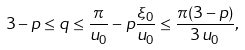<formula> <loc_0><loc_0><loc_500><loc_500>3 - p \leq q \leq \frac { \pi } { u _ { 0 } } - p \frac { \xi _ { 0 } } { u _ { 0 } } \leq \frac { \pi ( 3 - p ) } { 3 \, u _ { 0 } } ,</formula> 